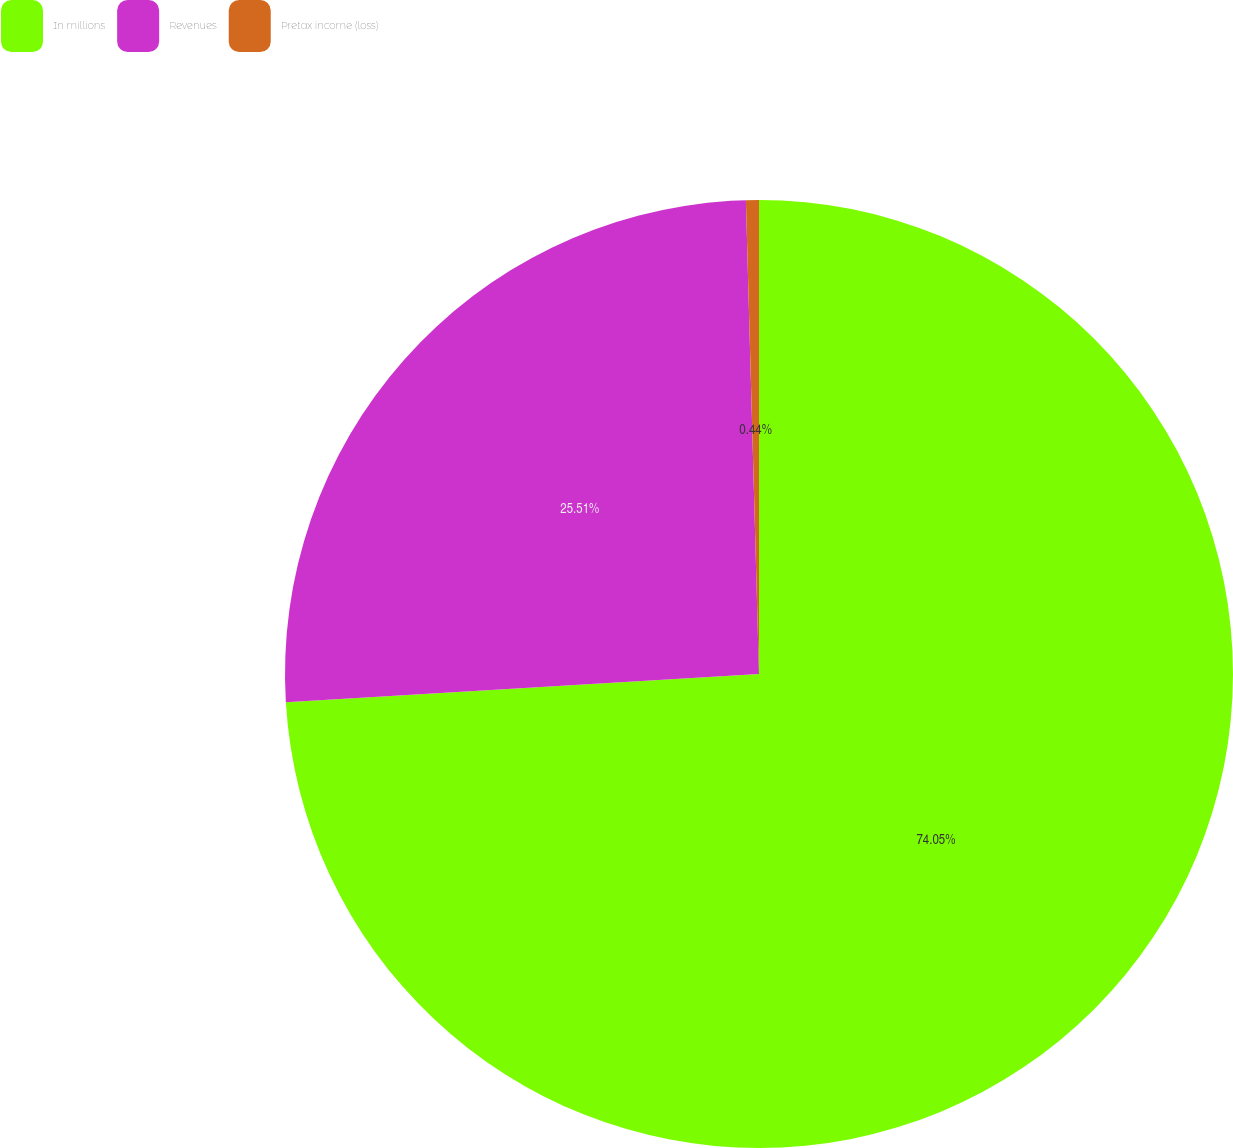Convert chart to OTSL. <chart><loc_0><loc_0><loc_500><loc_500><pie_chart><fcel>In millions<fcel>Revenues<fcel>Pretax income (loss)<nl><fcel>74.04%<fcel>25.51%<fcel>0.44%<nl></chart> 